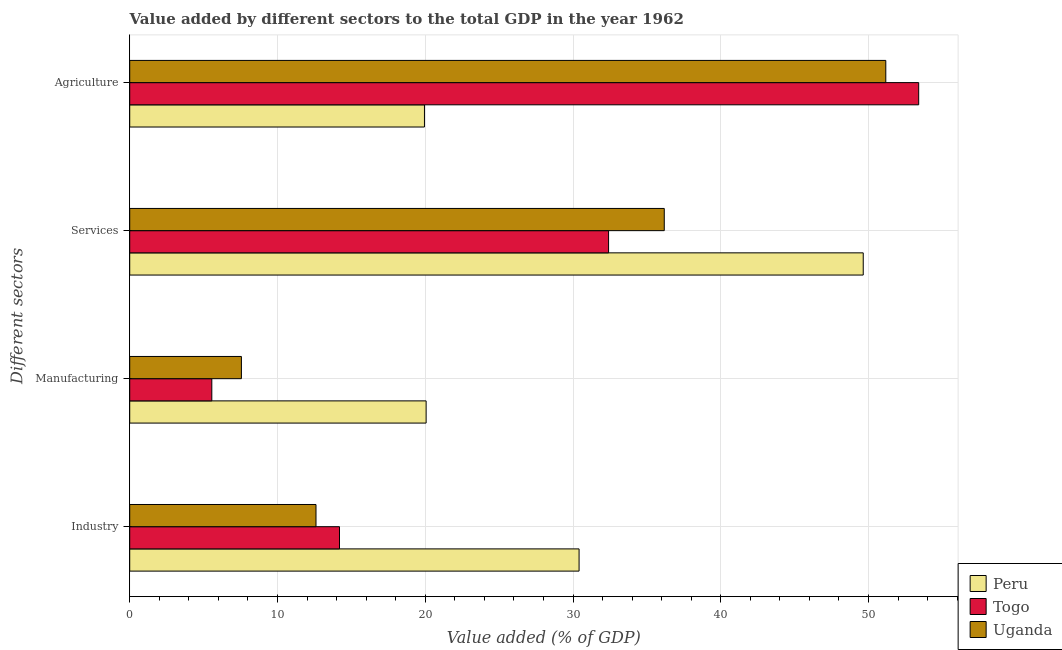How many different coloured bars are there?
Your response must be concise. 3. How many groups of bars are there?
Your response must be concise. 4. How many bars are there on the 4th tick from the top?
Your response must be concise. 3. How many bars are there on the 4th tick from the bottom?
Provide a succinct answer. 3. What is the label of the 4th group of bars from the top?
Your answer should be very brief. Industry. What is the value added by services sector in Togo?
Ensure brevity in your answer.  32.41. Across all countries, what is the maximum value added by services sector?
Your answer should be very brief. 49.64. Across all countries, what is the minimum value added by agricultural sector?
Provide a short and direct response. 19.95. In which country was the value added by agricultural sector maximum?
Your answer should be very brief. Togo. In which country was the value added by services sector minimum?
Your response must be concise. Togo. What is the total value added by industrial sector in the graph?
Provide a short and direct response. 57.22. What is the difference between the value added by manufacturing sector in Peru and that in Uganda?
Give a very brief answer. 12.5. What is the difference between the value added by services sector in Uganda and the value added by manufacturing sector in Peru?
Provide a succinct answer. 16.12. What is the average value added by manufacturing sector per country?
Ensure brevity in your answer.  11.06. What is the difference between the value added by services sector and value added by industrial sector in Uganda?
Your answer should be very brief. 23.57. What is the ratio of the value added by services sector in Togo to that in Peru?
Your answer should be compact. 0.65. Is the value added by agricultural sector in Uganda less than that in Togo?
Your answer should be very brief. Yes. What is the difference between the highest and the second highest value added by services sector?
Give a very brief answer. 13.47. What is the difference between the highest and the lowest value added by industrial sector?
Your response must be concise. 17.8. Is the sum of the value added by industrial sector in Uganda and Peru greater than the maximum value added by agricultural sector across all countries?
Make the answer very short. No. Is it the case that in every country, the sum of the value added by industrial sector and value added by agricultural sector is greater than the sum of value added by manufacturing sector and value added by services sector?
Your answer should be very brief. Yes. What does the 3rd bar from the top in Agriculture represents?
Provide a succinct answer. Peru. What does the 2nd bar from the bottom in Manufacturing represents?
Your answer should be very brief. Togo. Is it the case that in every country, the sum of the value added by industrial sector and value added by manufacturing sector is greater than the value added by services sector?
Give a very brief answer. No. Are the values on the major ticks of X-axis written in scientific E-notation?
Your answer should be compact. No. Does the graph contain any zero values?
Give a very brief answer. No. Does the graph contain grids?
Make the answer very short. Yes. How many legend labels are there?
Provide a succinct answer. 3. How are the legend labels stacked?
Your answer should be compact. Vertical. What is the title of the graph?
Provide a short and direct response. Value added by different sectors to the total GDP in the year 1962. What is the label or title of the X-axis?
Offer a very short reply. Value added (% of GDP). What is the label or title of the Y-axis?
Give a very brief answer. Different sectors. What is the Value added (% of GDP) of Peru in Industry?
Offer a very short reply. 30.41. What is the Value added (% of GDP) of Togo in Industry?
Offer a very short reply. 14.2. What is the Value added (% of GDP) in Uganda in Industry?
Provide a short and direct response. 12.61. What is the Value added (% of GDP) of Peru in Manufacturing?
Offer a very short reply. 20.06. What is the Value added (% of GDP) of Togo in Manufacturing?
Give a very brief answer. 5.56. What is the Value added (% of GDP) of Uganda in Manufacturing?
Offer a terse response. 7.56. What is the Value added (% of GDP) of Peru in Services?
Offer a terse response. 49.64. What is the Value added (% of GDP) in Togo in Services?
Your response must be concise. 32.41. What is the Value added (% of GDP) in Uganda in Services?
Your answer should be very brief. 36.18. What is the Value added (% of GDP) in Peru in Agriculture?
Ensure brevity in your answer.  19.95. What is the Value added (% of GDP) in Togo in Agriculture?
Your answer should be compact. 53.4. What is the Value added (% of GDP) in Uganda in Agriculture?
Provide a succinct answer. 51.17. Across all Different sectors, what is the maximum Value added (% of GDP) in Peru?
Make the answer very short. 49.64. Across all Different sectors, what is the maximum Value added (% of GDP) of Togo?
Provide a succinct answer. 53.4. Across all Different sectors, what is the maximum Value added (% of GDP) of Uganda?
Ensure brevity in your answer.  51.17. Across all Different sectors, what is the minimum Value added (% of GDP) in Peru?
Ensure brevity in your answer.  19.95. Across all Different sectors, what is the minimum Value added (% of GDP) of Togo?
Your answer should be compact. 5.56. Across all Different sectors, what is the minimum Value added (% of GDP) in Uganda?
Offer a terse response. 7.56. What is the total Value added (% of GDP) in Peru in the graph?
Your response must be concise. 120.06. What is the total Value added (% of GDP) of Togo in the graph?
Provide a succinct answer. 105.56. What is the total Value added (% of GDP) of Uganda in the graph?
Offer a terse response. 107.51. What is the difference between the Value added (% of GDP) in Peru in Industry and that in Manufacturing?
Provide a short and direct response. 10.35. What is the difference between the Value added (% of GDP) of Togo in Industry and that in Manufacturing?
Provide a succinct answer. 8.64. What is the difference between the Value added (% of GDP) in Uganda in Industry and that in Manufacturing?
Provide a succinct answer. 5.05. What is the difference between the Value added (% of GDP) of Peru in Industry and that in Services?
Provide a succinct answer. -19.23. What is the difference between the Value added (% of GDP) of Togo in Industry and that in Services?
Ensure brevity in your answer.  -18.21. What is the difference between the Value added (% of GDP) in Uganda in Industry and that in Services?
Provide a short and direct response. -23.57. What is the difference between the Value added (% of GDP) of Peru in Industry and that in Agriculture?
Your answer should be very brief. 10.46. What is the difference between the Value added (% of GDP) of Togo in Industry and that in Agriculture?
Provide a succinct answer. -39.2. What is the difference between the Value added (% of GDP) of Uganda in Industry and that in Agriculture?
Make the answer very short. -38.56. What is the difference between the Value added (% of GDP) in Peru in Manufacturing and that in Services?
Provide a short and direct response. -29.58. What is the difference between the Value added (% of GDP) of Togo in Manufacturing and that in Services?
Make the answer very short. -26.85. What is the difference between the Value added (% of GDP) of Uganda in Manufacturing and that in Services?
Offer a very short reply. -28.62. What is the difference between the Value added (% of GDP) of Peru in Manufacturing and that in Agriculture?
Make the answer very short. 0.11. What is the difference between the Value added (% of GDP) of Togo in Manufacturing and that in Agriculture?
Keep it short and to the point. -47.84. What is the difference between the Value added (% of GDP) of Uganda in Manufacturing and that in Agriculture?
Ensure brevity in your answer.  -43.61. What is the difference between the Value added (% of GDP) in Peru in Services and that in Agriculture?
Provide a succinct answer. 29.69. What is the difference between the Value added (% of GDP) of Togo in Services and that in Agriculture?
Offer a very short reply. -20.99. What is the difference between the Value added (% of GDP) of Uganda in Services and that in Agriculture?
Your response must be concise. -14.99. What is the difference between the Value added (% of GDP) of Peru in Industry and the Value added (% of GDP) of Togo in Manufacturing?
Provide a succinct answer. 24.86. What is the difference between the Value added (% of GDP) of Peru in Industry and the Value added (% of GDP) of Uganda in Manufacturing?
Make the answer very short. 22.85. What is the difference between the Value added (% of GDP) of Togo in Industry and the Value added (% of GDP) of Uganda in Manufacturing?
Keep it short and to the point. 6.64. What is the difference between the Value added (% of GDP) in Peru in Industry and the Value added (% of GDP) in Togo in Services?
Your answer should be compact. -2. What is the difference between the Value added (% of GDP) of Peru in Industry and the Value added (% of GDP) of Uganda in Services?
Provide a succinct answer. -5.76. What is the difference between the Value added (% of GDP) in Togo in Industry and the Value added (% of GDP) in Uganda in Services?
Provide a succinct answer. -21.98. What is the difference between the Value added (% of GDP) of Peru in Industry and the Value added (% of GDP) of Togo in Agriculture?
Give a very brief answer. -22.98. What is the difference between the Value added (% of GDP) in Peru in Industry and the Value added (% of GDP) in Uganda in Agriculture?
Your response must be concise. -20.76. What is the difference between the Value added (% of GDP) in Togo in Industry and the Value added (% of GDP) in Uganda in Agriculture?
Your answer should be compact. -36.97. What is the difference between the Value added (% of GDP) of Peru in Manufacturing and the Value added (% of GDP) of Togo in Services?
Your answer should be very brief. -12.35. What is the difference between the Value added (% of GDP) of Peru in Manufacturing and the Value added (% of GDP) of Uganda in Services?
Provide a short and direct response. -16.12. What is the difference between the Value added (% of GDP) of Togo in Manufacturing and the Value added (% of GDP) of Uganda in Services?
Provide a short and direct response. -30.62. What is the difference between the Value added (% of GDP) in Peru in Manufacturing and the Value added (% of GDP) in Togo in Agriculture?
Make the answer very short. -33.33. What is the difference between the Value added (% of GDP) in Peru in Manufacturing and the Value added (% of GDP) in Uganda in Agriculture?
Offer a very short reply. -31.11. What is the difference between the Value added (% of GDP) of Togo in Manufacturing and the Value added (% of GDP) of Uganda in Agriculture?
Give a very brief answer. -45.61. What is the difference between the Value added (% of GDP) of Peru in Services and the Value added (% of GDP) of Togo in Agriculture?
Provide a short and direct response. -3.75. What is the difference between the Value added (% of GDP) in Peru in Services and the Value added (% of GDP) in Uganda in Agriculture?
Provide a succinct answer. -1.53. What is the difference between the Value added (% of GDP) of Togo in Services and the Value added (% of GDP) of Uganda in Agriculture?
Keep it short and to the point. -18.76. What is the average Value added (% of GDP) of Peru per Different sectors?
Your answer should be compact. 30.02. What is the average Value added (% of GDP) in Togo per Different sectors?
Your answer should be very brief. 26.39. What is the average Value added (% of GDP) of Uganda per Different sectors?
Your answer should be very brief. 26.88. What is the difference between the Value added (% of GDP) of Peru and Value added (% of GDP) of Togo in Industry?
Offer a terse response. 16.21. What is the difference between the Value added (% of GDP) in Peru and Value added (% of GDP) in Uganda in Industry?
Ensure brevity in your answer.  17.8. What is the difference between the Value added (% of GDP) in Togo and Value added (% of GDP) in Uganda in Industry?
Ensure brevity in your answer.  1.59. What is the difference between the Value added (% of GDP) in Peru and Value added (% of GDP) in Togo in Manufacturing?
Keep it short and to the point. 14.5. What is the difference between the Value added (% of GDP) of Peru and Value added (% of GDP) of Uganda in Manufacturing?
Give a very brief answer. 12.5. What is the difference between the Value added (% of GDP) in Togo and Value added (% of GDP) in Uganda in Manufacturing?
Make the answer very short. -2. What is the difference between the Value added (% of GDP) in Peru and Value added (% of GDP) in Togo in Services?
Your answer should be compact. 17.23. What is the difference between the Value added (% of GDP) in Peru and Value added (% of GDP) in Uganda in Services?
Your response must be concise. 13.47. What is the difference between the Value added (% of GDP) in Togo and Value added (% of GDP) in Uganda in Services?
Your answer should be very brief. -3.77. What is the difference between the Value added (% of GDP) of Peru and Value added (% of GDP) of Togo in Agriculture?
Make the answer very short. -33.45. What is the difference between the Value added (% of GDP) in Peru and Value added (% of GDP) in Uganda in Agriculture?
Keep it short and to the point. -31.22. What is the difference between the Value added (% of GDP) in Togo and Value added (% of GDP) in Uganda in Agriculture?
Ensure brevity in your answer.  2.23. What is the ratio of the Value added (% of GDP) of Peru in Industry to that in Manufacturing?
Your answer should be very brief. 1.52. What is the ratio of the Value added (% of GDP) in Togo in Industry to that in Manufacturing?
Give a very brief answer. 2.56. What is the ratio of the Value added (% of GDP) of Uganda in Industry to that in Manufacturing?
Make the answer very short. 1.67. What is the ratio of the Value added (% of GDP) of Peru in Industry to that in Services?
Your answer should be very brief. 0.61. What is the ratio of the Value added (% of GDP) of Togo in Industry to that in Services?
Make the answer very short. 0.44. What is the ratio of the Value added (% of GDP) in Uganda in Industry to that in Services?
Make the answer very short. 0.35. What is the ratio of the Value added (% of GDP) in Peru in Industry to that in Agriculture?
Offer a very short reply. 1.52. What is the ratio of the Value added (% of GDP) in Togo in Industry to that in Agriculture?
Offer a very short reply. 0.27. What is the ratio of the Value added (% of GDP) in Uganda in Industry to that in Agriculture?
Ensure brevity in your answer.  0.25. What is the ratio of the Value added (% of GDP) of Peru in Manufacturing to that in Services?
Your response must be concise. 0.4. What is the ratio of the Value added (% of GDP) of Togo in Manufacturing to that in Services?
Offer a terse response. 0.17. What is the ratio of the Value added (% of GDP) of Uganda in Manufacturing to that in Services?
Provide a short and direct response. 0.21. What is the ratio of the Value added (% of GDP) of Peru in Manufacturing to that in Agriculture?
Make the answer very short. 1.01. What is the ratio of the Value added (% of GDP) in Togo in Manufacturing to that in Agriculture?
Your response must be concise. 0.1. What is the ratio of the Value added (% of GDP) of Uganda in Manufacturing to that in Agriculture?
Offer a terse response. 0.15. What is the ratio of the Value added (% of GDP) in Peru in Services to that in Agriculture?
Your response must be concise. 2.49. What is the ratio of the Value added (% of GDP) of Togo in Services to that in Agriculture?
Make the answer very short. 0.61. What is the ratio of the Value added (% of GDP) in Uganda in Services to that in Agriculture?
Provide a short and direct response. 0.71. What is the difference between the highest and the second highest Value added (% of GDP) in Peru?
Keep it short and to the point. 19.23. What is the difference between the highest and the second highest Value added (% of GDP) in Togo?
Offer a terse response. 20.99. What is the difference between the highest and the second highest Value added (% of GDP) in Uganda?
Your answer should be compact. 14.99. What is the difference between the highest and the lowest Value added (% of GDP) of Peru?
Give a very brief answer. 29.69. What is the difference between the highest and the lowest Value added (% of GDP) in Togo?
Provide a short and direct response. 47.84. What is the difference between the highest and the lowest Value added (% of GDP) of Uganda?
Offer a terse response. 43.61. 